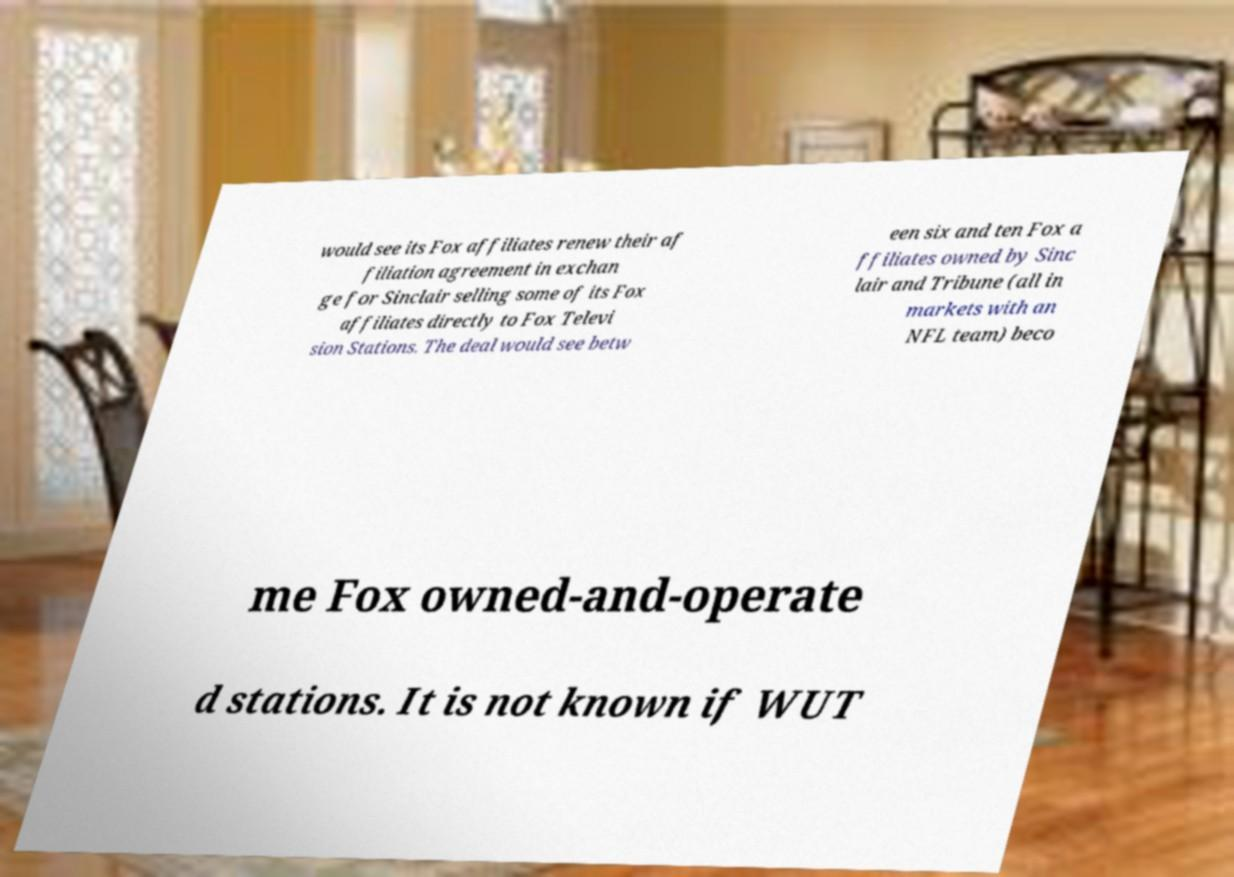Could you extract and type out the text from this image? would see its Fox affiliates renew their af filiation agreement in exchan ge for Sinclair selling some of its Fox affiliates directly to Fox Televi sion Stations. The deal would see betw een six and ten Fox a ffiliates owned by Sinc lair and Tribune (all in markets with an NFL team) beco me Fox owned-and-operate d stations. It is not known if WUT 